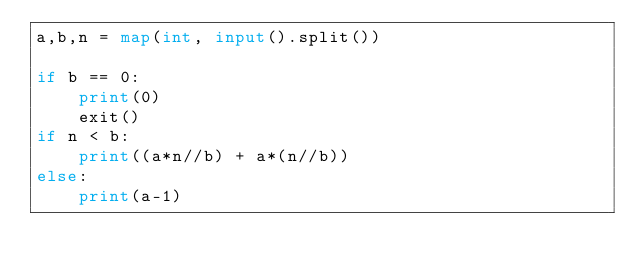<code> <loc_0><loc_0><loc_500><loc_500><_Python_>a,b,n = map(int, input().split())

if b == 0:
    print(0)
    exit()
if n < b:
    print((a*n//b) + a*(n//b))
else:
    print(a-1)
    </code> 